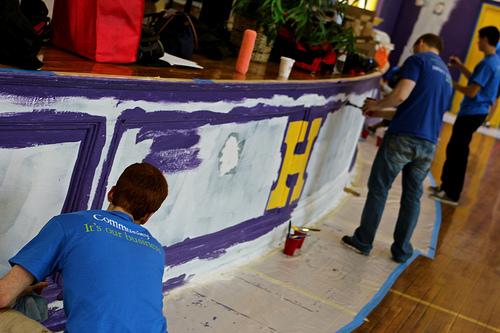<image>
Is there a letter h on the stage front? Yes. Looking at the image, I can see the letter h is positioned on top of the stage front, with the stage front providing support. 